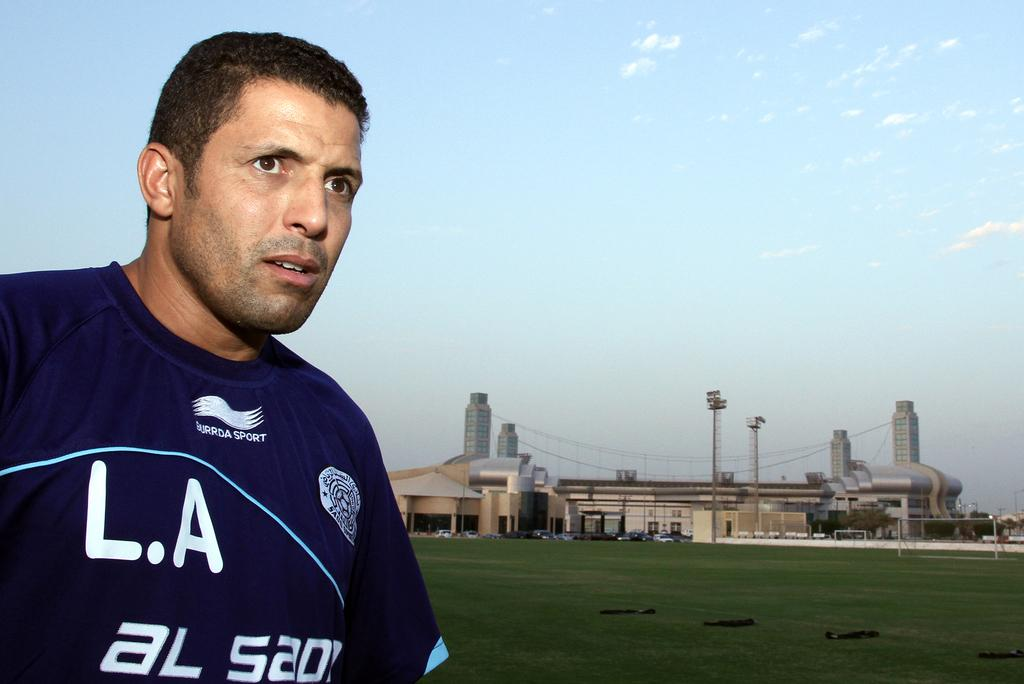<image>
Present a compact description of the photo's key features. A man in a shirt with"LA" on it is standing in a grassy lawn. 